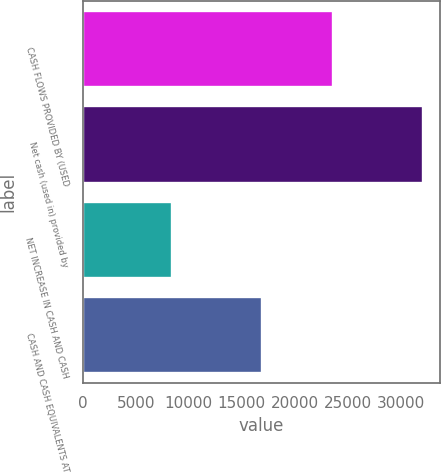Convert chart to OTSL. <chart><loc_0><loc_0><loc_500><loc_500><bar_chart><fcel>CASH FLOWS PROVIDED BY (USED<fcel>Net cash (used in) provided by<fcel>NET INCREASE IN CASH AND CASH<fcel>CASH AND CASH EQUIVALENTS AT<nl><fcel>23643<fcel>32053<fcel>8410<fcel>16889<nl></chart> 